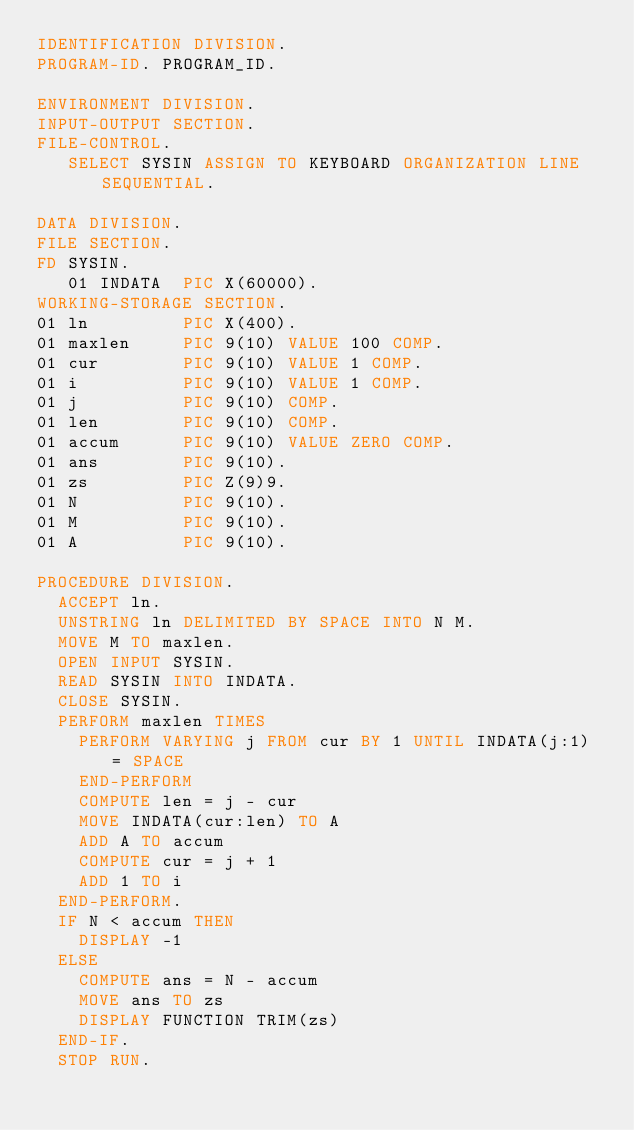Convert code to text. <code><loc_0><loc_0><loc_500><loc_500><_COBOL_>IDENTIFICATION DIVISION.
PROGRAM-ID. PROGRAM_ID.

ENVIRONMENT DIVISION.
INPUT-OUTPUT SECTION.
FILE-CONTROL.
   SELECT SYSIN ASSIGN TO KEYBOARD ORGANIZATION LINE SEQUENTIAL.

DATA DIVISION.
FILE SECTION.
FD SYSIN.
   01 INDATA  PIC X(60000).
WORKING-STORAGE SECTION.
01 ln         PIC X(400).
01 maxlen     PIC 9(10) VALUE 100 COMP.
01 cur        PIC 9(10) VALUE 1 COMP.
01 i          PIC 9(10) VALUE 1 COMP.
01 j          PIC 9(10) COMP.
01 len        PIC 9(10) COMP.
01 accum      PIC 9(10) VALUE ZERO COMP.
01 ans        PIC 9(10).
01 zs         PIC Z(9)9.
01 N          PIC 9(10).
01 M          PIC 9(10).
01 A          PIC 9(10).

PROCEDURE DIVISION.
  ACCEPT ln.
  UNSTRING ln DELIMITED BY SPACE INTO N M.
  MOVE M TO maxlen.
  OPEN INPUT SYSIN.
  READ SYSIN INTO INDATA.
  CLOSE SYSIN.
  PERFORM maxlen TIMES
    PERFORM VARYING j FROM cur BY 1 UNTIL INDATA(j:1) = SPACE
    END-PERFORM
    COMPUTE len = j - cur
    MOVE INDATA(cur:len) TO A
    ADD A TO accum
    COMPUTE cur = j + 1
    ADD 1 TO i
  END-PERFORM.
  IF N < accum THEN
    DISPLAY -1
  ELSE
    COMPUTE ans = N - accum
    MOVE ans TO zs
    DISPLAY FUNCTION TRIM(zs)
  END-IF.
  STOP RUN.
</code> 